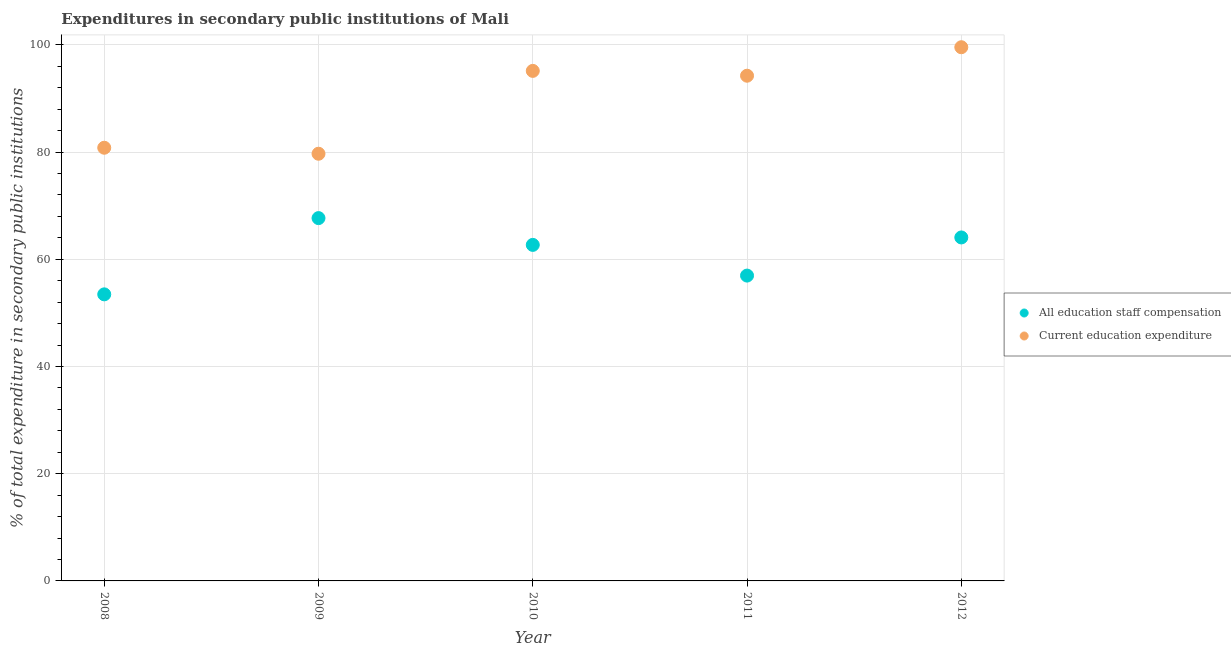How many different coloured dotlines are there?
Offer a terse response. 2. Is the number of dotlines equal to the number of legend labels?
Your answer should be compact. Yes. What is the expenditure in education in 2012?
Your answer should be very brief. 99.55. Across all years, what is the maximum expenditure in staff compensation?
Give a very brief answer. 67.68. Across all years, what is the minimum expenditure in staff compensation?
Offer a very short reply. 53.46. In which year was the expenditure in education maximum?
Make the answer very short. 2012. What is the total expenditure in staff compensation in the graph?
Provide a succinct answer. 304.85. What is the difference between the expenditure in education in 2008 and that in 2012?
Give a very brief answer. -18.75. What is the difference between the expenditure in education in 2010 and the expenditure in staff compensation in 2012?
Give a very brief answer. 31.07. What is the average expenditure in staff compensation per year?
Provide a succinct answer. 60.97. In the year 2012, what is the difference between the expenditure in education and expenditure in staff compensation?
Give a very brief answer. 35.48. What is the ratio of the expenditure in staff compensation in 2009 to that in 2011?
Your answer should be very brief. 1.19. Is the difference between the expenditure in education in 2010 and 2011 greater than the difference between the expenditure in staff compensation in 2010 and 2011?
Offer a very short reply. No. What is the difference between the highest and the second highest expenditure in staff compensation?
Your answer should be very brief. 3.61. What is the difference between the highest and the lowest expenditure in staff compensation?
Ensure brevity in your answer.  14.22. In how many years, is the expenditure in education greater than the average expenditure in education taken over all years?
Offer a very short reply. 3. Is the sum of the expenditure in staff compensation in 2010 and 2011 greater than the maximum expenditure in education across all years?
Provide a succinct answer. Yes. Does the expenditure in education monotonically increase over the years?
Ensure brevity in your answer.  No. Is the expenditure in education strictly greater than the expenditure in staff compensation over the years?
Provide a short and direct response. Yes. How many years are there in the graph?
Your response must be concise. 5. What is the difference between two consecutive major ticks on the Y-axis?
Provide a short and direct response. 20. Are the values on the major ticks of Y-axis written in scientific E-notation?
Your answer should be compact. No. Does the graph contain any zero values?
Keep it short and to the point. No. Where does the legend appear in the graph?
Keep it short and to the point. Center right. How are the legend labels stacked?
Give a very brief answer. Vertical. What is the title of the graph?
Keep it short and to the point. Expenditures in secondary public institutions of Mali. Does "Canada" appear as one of the legend labels in the graph?
Give a very brief answer. No. What is the label or title of the X-axis?
Provide a succinct answer. Year. What is the label or title of the Y-axis?
Offer a very short reply. % of total expenditure in secondary public institutions. What is the % of total expenditure in secondary public institutions of All education staff compensation in 2008?
Your response must be concise. 53.46. What is the % of total expenditure in secondary public institutions in Current education expenditure in 2008?
Your response must be concise. 80.81. What is the % of total expenditure in secondary public institutions of All education staff compensation in 2009?
Keep it short and to the point. 67.68. What is the % of total expenditure in secondary public institutions in Current education expenditure in 2009?
Offer a terse response. 79.69. What is the % of total expenditure in secondary public institutions of All education staff compensation in 2010?
Provide a short and direct response. 62.68. What is the % of total expenditure in secondary public institutions of Current education expenditure in 2010?
Provide a short and direct response. 95.14. What is the % of total expenditure in secondary public institutions of All education staff compensation in 2011?
Keep it short and to the point. 56.96. What is the % of total expenditure in secondary public institutions in Current education expenditure in 2011?
Keep it short and to the point. 94.24. What is the % of total expenditure in secondary public institutions of All education staff compensation in 2012?
Your answer should be very brief. 64.07. What is the % of total expenditure in secondary public institutions in Current education expenditure in 2012?
Provide a succinct answer. 99.55. Across all years, what is the maximum % of total expenditure in secondary public institutions of All education staff compensation?
Ensure brevity in your answer.  67.68. Across all years, what is the maximum % of total expenditure in secondary public institutions of Current education expenditure?
Give a very brief answer. 99.55. Across all years, what is the minimum % of total expenditure in secondary public institutions of All education staff compensation?
Your answer should be compact. 53.46. Across all years, what is the minimum % of total expenditure in secondary public institutions of Current education expenditure?
Keep it short and to the point. 79.69. What is the total % of total expenditure in secondary public institutions of All education staff compensation in the graph?
Offer a very short reply. 304.85. What is the total % of total expenditure in secondary public institutions of Current education expenditure in the graph?
Make the answer very short. 449.43. What is the difference between the % of total expenditure in secondary public institutions in All education staff compensation in 2008 and that in 2009?
Give a very brief answer. -14.22. What is the difference between the % of total expenditure in secondary public institutions in Current education expenditure in 2008 and that in 2009?
Give a very brief answer. 1.12. What is the difference between the % of total expenditure in secondary public institutions in All education staff compensation in 2008 and that in 2010?
Keep it short and to the point. -9.23. What is the difference between the % of total expenditure in secondary public institutions in Current education expenditure in 2008 and that in 2010?
Offer a very short reply. -14.34. What is the difference between the % of total expenditure in secondary public institutions in All education staff compensation in 2008 and that in 2011?
Ensure brevity in your answer.  -3.5. What is the difference between the % of total expenditure in secondary public institutions in Current education expenditure in 2008 and that in 2011?
Make the answer very short. -13.44. What is the difference between the % of total expenditure in secondary public institutions of All education staff compensation in 2008 and that in 2012?
Offer a very short reply. -10.62. What is the difference between the % of total expenditure in secondary public institutions in Current education expenditure in 2008 and that in 2012?
Your answer should be compact. -18.75. What is the difference between the % of total expenditure in secondary public institutions in All education staff compensation in 2009 and that in 2010?
Your answer should be very brief. 5. What is the difference between the % of total expenditure in secondary public institutions in Current education expenditure in 2009 and that in 2010?
Offer a terse response. -15.45. What is the difference between the % of total expenditure in secondary public institutions in All education staff compensation in 2009 and that in 2011?
Provide a short and direct response. 10.72. What is the difference between the % of total expenditure in secondary public institutions in Current education expenditure in 2009 and that in 2011?
Your answer should be very brief. -14.55. What is the difference between the % of total expenditure in secondary public institutions of All education staff compensation in 2009 and that in 2012?
Offer a terse response. 3.61. What is the difference between the % of total expenditure in secondary public institutions of Current education expenditure in 2009 and that in 2012?
Provide a succinct answer. -19.87. What is the difference between the % of total expenditure in secondary public institutions in All education staff compensation in 2010 and that in 2011?
Your answer should be very brief. 5.73. What is the difference between the % of total expenditure in secondary public institutions in Current education expenditure in 2010 and that in 2011?
Your response must be concise. 0.9. What is the difference between the % of total expenditure in secondary public institutions in All education staff compensation in 2010 and that in 2012?
Make the answer very short. -1.39. What is the difference between the % of total expenditure in secondary public institutions in Current education expenditure in 2010 and that in 2012?
Make the answer very short. -4.41. What is the difference between the % of total expenditure in secondary public institutions in All education staff compensation in 2011 and that in 2012?
Your answer should be compact. -7.11. What is the difference between the % of total expenditure in secondary public institutions of Current education expenditure in 2011 and that in 2012?
Offer a terse response. -5.31. What is the difference between the % of total expenditure in secondary public institutions in All education staff compensation in 2008 and the % of total expenditure in secondary public institutions in Current education expenditure in 2009?
Provide a succinct answer. -26.23. What is the difference between the % of total expenditure in secondary public institutions in All education staff compensation in 2008 and the % of total expenditure in secondary public institutions in Current education expenditure in 2010?
Give a very brief answer. -41.69. What is the difference between the % of total expenditure in secondary public institutions of All education staff compensation in 2008 and the % of total expenditure in secondary public institutions of Current education expenditure in 2011?
Keep it short and to the point. -40.78. What is the difference between the % of total expenditure in secondary public institutions in All education staff compensation in 2008 and the % of total expenditure in secondary public institutions in Current education expenditure in 2012?
Provide a short and direct response. -46.1. What is the difference between the % of total expenditure in secondary public institutions of All education staff compensation in 2009 and the % of total expenditure in secondary public institutions of Current education expenditure in 2010?
Provide a succinct answer. -27.46. What is the difference between the % of total expenditure in secondary public institutions in All education staff compensation in 2009 and the % of total expenditure in secondary public institutions in Current education expenditure in 2011?
Your answer should be very brief. -26.56. What is the difference between the % of total expenditure in secondary public institutions in All education staff compensation in 2009 and the % of total expenditure in secondary public institutions in Current education expenditure in 2012?
Make the answer very short. -31.87. What is the difference between the % of total expenditure in secondary public institutions of All education staff compensation in 2010 and the % of total expenditure in secondary public institutions of Current education expenditure in 2011?
Your answer should be very brief. -31.56. What is the difference between the % of total expenditure in secondary public institutions of All education staff compensation in 2010 and the % of total expenditure in secondary public institutions of Current education expenditure in 2012?
Offer a terse response. -36.87. What is the difference between the % of total expenditure in secondary public institutions of All education staff compensation in 2011 and the % of total expenditure in secondary public institutions of Current education expenditure in 2012?
Provide a short and direct response. -42.6. What is the average % of total expenditure in secondary public institutions in All education staff compensation per year?
Your answer should be very brief. 60.97. What is the average % of total expenditure in secondary public institutions of Current education expenditure per year?
Give a very brief answer. 89.89. In the year 2008, what is the difference between the % of total expenditure in secondary public institutions in All education staff compensation and % of total expenditure in secondary public institutions in Current education expenditure?
Your response must be concise. -27.35. In the year 2009, what is the difference between the % of total expenditure in secondary public institutions in All education staff compensation and % of total expenditure in secondary public institutions in Current education expenditure?
Keep it short and to the point. -12.01. In the year 2010, what is the difference between the % of total expenditure in secondary public institutions of All education staff compensation and % of total expenditure in secondary public institutions of Current education expenditure?
Your answer should be compact. -32.46. In the year 2011, what is the difference between the % of total expenditure in secondary public institutions in All education staff compensation and % of total expenditure in secondary public institutions in Current education expenditure?
Provide a succinct answer. -37.28. In the year 2012, what is the difference between the % of total expenditure in secondary public institutions in All education staff compensation and % of total expenditure in secondary public institutions in Current education expenditure?
Ensure brevity in your answer.  -35.48. What is the ratio of the % of total expenditure in secondary public institutions of All education staff compensation in 2008 to that in 2009?
Keep it short and to the point. 0.79. What is the ratio of the % of total expenditure in secondary public institutions of Current education expenditure in 2008 to that in 2009?
Your answer should be compact. 1.01. What is the ratio of the % of total expenditure in secondary public institutions of All education staff compensation in 2008 to that in 2010?
Give a very brief answer. 0.85. What is the ratio of the % of total expenditure in secondary public institutions of Current education expenditure in 2008 to that in 2010?
Offer a very short reply. 0.85. What is the ratio of the % of total expenditure in secondary public institutions of All education staff compensation in 2008 to that in 2011?
Provide a succinct answer. 0.94. What is the ratio of the % of total expenditure in secondary public institutions in Current education expenditure in 2008 to that in 2011?
Give a very brief answer. 0.86. What is the ratio of the % of total expenditure in secondary public institutions of All education staff compensation in 2008 to that in 2012?
Offer a terse response. 0.83. What is the ratio of the % of total expenditure in secondary public institutions of Current education expenditure in 2008 to that in 2012?
Give a very brief answer. 0.81. What is the ratio of the % of total expenditure in secondary public institutions in All education staff compensation in 2009 to that in 2010?
Offer a very short reply. 1.08. What is the ratio of the % of total expenditure in secondary public institutions of Current education expenditure in 2009 to that in 2010?
Offer a terse response. 0.84. What is the ratio of the % of total expenditure in secondary public institutions of All education staff compensation in 2009 to that in 2011?
Give a very brief answer. 1.19. What is the ratio of the % of total expenditure in secondary public institutions in Current education expenditure in 2009 to that in 2011?
Make the answer very short. 0.85. What is the ratio of the % of total expenditure in secondary public institutions of All education staff compensation in 2009 to that in 2012?
Provide a short and direct response. 1.06. What is the ratio of the % of total expenditure in secondary public institutions in Current education expenditure in 2009 to that in 2012?
Provide a short and direct response. 0.8. What is the ratio of the % of total expenditure in secondary public institutions of All education staff compensation in 2010 to that in 2011?
Provide a short and direct response. 1.1. What is the ratio of the % of total expenditure in secondary public institutions in Current education expenditure in 2010 to that in 2011?
Keep it short and to the point. 1.01. What is the ratio of the % of total expenditure in secondary public institutions in All education staff compensation in 2010 to that in 2012?
Your response must be concise. 0.98. What is the ratio of the % of total expenditure in secondary public institutions in Current education expenditure in 2010 to that in 2012?
Make the answer very short. 0.96. What is the ratio of the % of total expenditure in secondary public institutions in All education staff compensation in 2011 to that in 2012?
Make the answer very short. 0.89. What is the ratio of the % of total expenditure in secondary public institutions of Current education expenditure in 2011 to that in 2012?
Your response must be concise. 0.95. What is the difference between the highest and the second highest % of total expenditure in secondary public institutions of All education staff compensation?
Give a very brief answer. 3.61. What is the difference between the highest and the second highest % of total expenditure in secondary public institutions of Current education expenditure?
Provide a succinct answer. 4.41. What is the difference between the highest and the lowest % of total expenditure in secondary public institutions of All education staff compensation?
Provide a short and direct response. 14.22. What is the difference between the highest and the lowest % of total expenditure in secondary public institutions in Current education expenditure?
Your answer should be very brief. 19.87. 